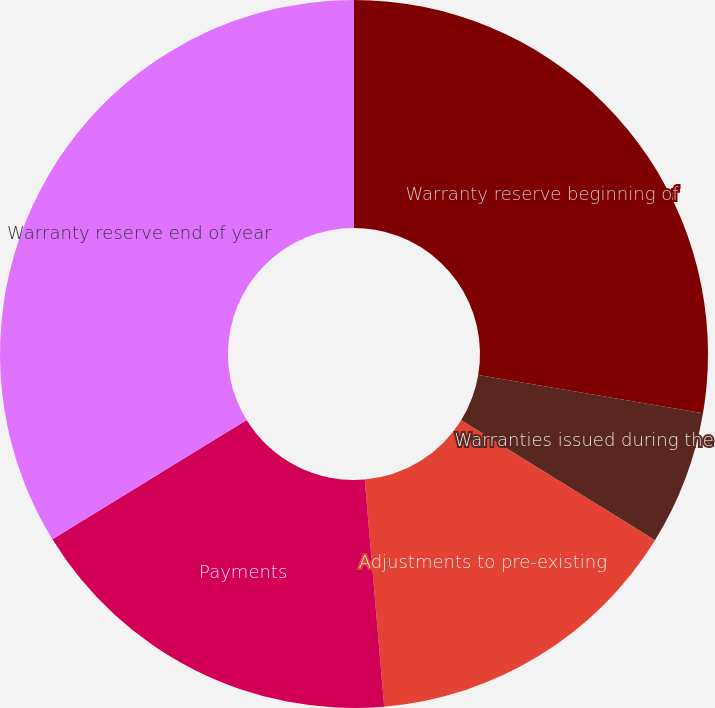<chart> <loc_0><loc_0><loc_500><loc_500><pie_chart><fcel>Warranty reserve beginning of<fcel>Warranties issued during the<fcel>Adjustments to pre-existing<fcel>Payments<fcel>Warranty reserve end of year<nl><fcel>27.68%<fcel>6.14%<fcel>14.82%<fcel>17.59%<fcel>33.77%<nl></chart> 